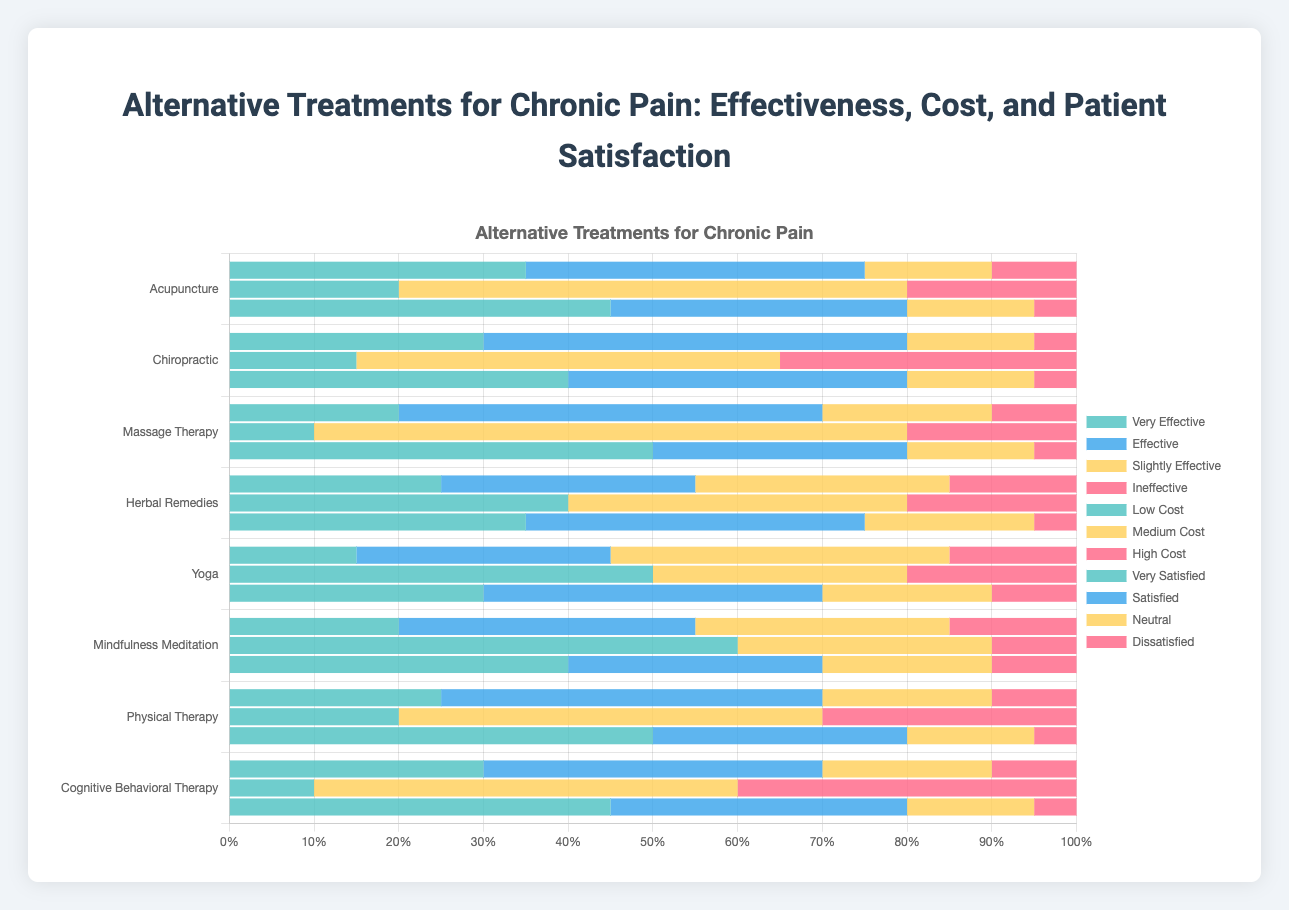Which treatment has the highest percentage of patients who are very satisfied? Reviewing the patient satisfaction data, Massage Therapy has the highest percentage of patients who are very satisfied with 50%.
Answer: Massage Therapy Between Yoga and Mindfulness Meditation, which treatment has a higher percentage of patients who found it very effective? Comparing the very effective percentages, Yoga has 15% while Mindfulness Meditation has 20%. Thus, Mindfulness Meditation has a higher percentage.
Answer: Mindfulness Meditation What is the combined percentage of patients who found Cognitive Behavioral Therapy either very effective or effective? Adding the percentages of very effective (30%) and effective (40%) for Cognitive Behavioral Therapy, we get 30% + 40% = 70%.
Answer: 70% Which treatment is considered the most costly by patients? By examining the high-cost data, Chiropractic has the highest percentage of high costs at 35%.
Answer: Chiropractic Can you list the treatments with the majority of patients rating their cost as low? Mindfulness Meditation (60%) and Yoga (50%) have the majority of patients rating their cost as low since their low-cost percentages exceed 50%.
Answer: Mindfulness Meditation, Yoga What treatment has the lowest percentage of patients who found it ineffective? Comparing the ineffective percentages, Chiropractic has the lowest percentage at 5%.
Answer: Chiropractic Calculate the average percentage of patients who are neutral about their patient satisfaction for Acupuncture, Massage Therapy, and Cognitive Behavioral Therapy. For Acupuncture (15%), Massage Therapy (15%), and Cognitive Behavioral Therapy (15%), the average is calculated as (15 + 15 + 15)/3 = 15%.
Answer: 15% Which two treatments have the highest percentage of patients who found them slightly effective? Yoga (40%) and Herbal Remedies (30%) have the highest and second-highest percentages of patients who found them slightly effective.
Answer: Yoga, Herbal Remedies What is the total percentage of patients dissatisfied with Physical Therapy across all categories? Adding the dissatisfied percentage (5%) with every satisfaction percentage gives us just one value: 5%.
Answer: 5% Among Herbal Remedies and Acupuncture, which treatment has a lower percentage of patients considering it medium cost? Looking at medium cost, Herbal Remedies has 40% while Acupuncture has 60%. Thus, Herbal Remedies has a lower percentage.
Answer: Herbal Remedies 